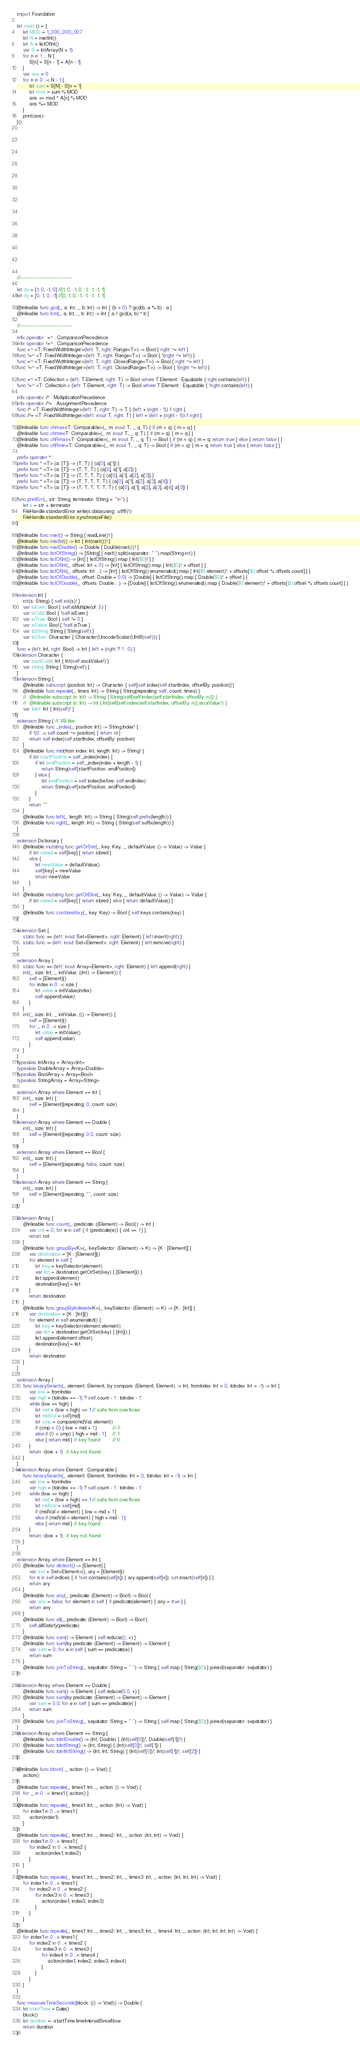Convert code to text. <code><loc_0><loc_0><loc_500><loc_500><_Swift_>import Foundation

let main: () = {
    let MOD = 1_000_000_007
    let N = nextInt()
    let A = listOfInt()
    var S = IntArray(N + 1)
    for n in 1 ... N {
        S[n] = S[n - 1] + A[n - 1]
    }
    var ans = 0
    for n in 0 ..< N - 1 {
        let sum = S[N] - S[n + 1]
        let mod = sum % MOD
        ans += mod * A[n] % MOD
        ans %= MOD
    }
    print(ans)
}()

























//----------------------------------

let dx = [1, 0, -1, 0] //[1, 0, -1, 0, -1,  1, -1, 1]
let dy = [0, 1, 0, -1] //[0, 1, 0, -1, -1, -1,  1, 1]

@inlinable func gcd(_ a: Int, _ b: Int) -> Int { (b > 0) ? gcd(b, a % b) : a }
@inlinable func lcm(_ a: Int, _ b: Int) -> Int { a / gcd(a, b) * b }

//----------------------------------

infix operator  =~ : ComparisonPrecedence
infix operator !=~ : ComparisonPrecedence
func =~ <T: FixedWidthInteger>(left: T, right: Range<T>) -> Bool { right ~= left }
func !=~ <T: FixedWidthInteger>(left: T, right: Range<T>) -> Bool { !(right ~= left) }
func =~ <T: FixedWidthInteger>(left: T, right: ClosedRange<T>) -> Bool { right ~= left }
func !=~ <T: FixedWidthInteger>(left: T, right: ClosedRange<T>) -> Bool { !(right ~= left) }

func =~ <T: Collection > (left: T.Element, right: T) -> Bool where T.Element : Equatable { right.contains(left) }
func !=~ <T: Collection > (left: T.Element, right: T) -> Bool where T.Element : Equatable { !right.contains(left) }

infix operator /^ : MultiplicationPrecedence
infix operator /^= : AssignmentPrecedence
func /^ <T: FixedWidthInteger>(left: T, right: T) -> T { (left + (right - 1)) / right }
func /^= <T: FixedWidthInteger>(left: inout T, right: T) { left = (left + (right - 1)) / right }

@inlinable func chmax<T: Comparable>(_ m: inout T, _ q: T) { if (m < q) { m = q } }
@inlinable func chmin<T: Comparable>(_ m: inout T, _ q: T) { if (m > q) { m = q } }
@inlinable func chRmax<T: Comparable>(_ m: inout T, _ q: T) -> Bool { if (m < q) { m = q; return true } else { return false } }
@inlinable func chRmin<T: Comparable>(_ m: inout T, _ q: T) -> Bool { if (m > q) { m = q; return true } else { return false } }

prefix operator *
prefix func * <T> (a: [T]) -> (T, T) { (a[0], a[1]) }
prefix func * <T> (a: [T]) -> (T, T, T) { (a[0], a[1], a[2]) }
prefix func * <T> (a: [T]) -> (T, T, T, T) { (a[0], a[1], a[2], a[3]) }
prefix func * <T> (a: [T]) -> (T, T, T, T, T) { (a[0], a[1], a[2], a[3], a[4]) }
prefix func * <T> (a: [T]) -> (T, T, T, T, T, T) { (a[0], a[1], a[2], a[3], a[4], a[5]) }

func printErr(_ str: String, terminator: String = "\n") {
    let s = str + terminator
    FileHandle.standardError.write(s.data(using: .utf8)!)
    FileHandle.standardError.synchronizeFile()
}

@inlinable func next() -> String { readLine()! }
@inlinable func nextInt() -> Int { Int(next())! }
@inlinable func nextDouble() -> Double { Double(next())! }
@inlinable func listOfString() -> [String] { next().split(separator: " ").map(String.init) }
@inlinable func listOfInt() -> [Int] { listOfString().map { Int($0)! } }
@inlinable func listOfInt(_ offset: Int = 0) -> [Int] { listOfString().map { Int($0)! + offset } }
@inlinable func listOfInt(_ offsets: Int ...) -> [Int] { listOfString().enumerated().map { Int($0.element)! + offsets[$0.offset % offsets.count] } }
@inlinable func listOfDouble(_ offset: Double = 0.0) -> [Double] { listOfString().map { Double($0)! + offset } }
@inlinable func listOfDouble(_ offsets: Double ...) -> [Double] { listOfString().enumerated().map { Double($0.element)! + offsets[$0.offset % offsets.count] } }

extension Int {
    init(s: String) { self.init(s)! }
    var isEven: Bool { self.isMultiple(of: 2) }
    var isOdd: Bool { !self.isEven }
    var isTrue: Bool { self != 0 }
    var isFalse: Bool { !self.isTrue }
    var toString: String { String(self) }
    var toChar: Character { Character(UnicodeScalar(UInt8(self))) }
}
func + (left: Int, right: Bool) -> Int { left + (right ? 1 : 0) }
extension Character {
    var asciiCode: Int { Int(self.asciiValue!) }
    var string: String { String(self) }
}
extension String {
    @inlinable subscript (position: Int) -> Character { self[self.index(self.startIndex, offsetBy: position)] }
    @inlinable func repeate(_ times: Int) -> String { String(repeating: self, count: times) }
    //  @inlinable subscript (n: Int) -> String { String(self[self.index(self.startIndex, offsetBy: n)]) }
    //  @inlinable subscript (n: Int) -> Int { Int(self[self.index(self.startIndex, offsetBy: n)].asciiValue!) }
    var toInt: Int { Int(self)! }
}
extension String { // VB like
    @inlinable func _index(_ position: Int) -> String.Index! {
        if !(0 ..< self.count ~= position) { return nil }
        return self.index(self.startIndex, offsetBy: position)
    }
    @inlinable func mid(from index: Int, length: Int) -> String! {
        if let startPosition = self._index(index) {
            if let endPosition = self._index(index + length - 1) {
                return String(self[startPosition...endPosition])
            } else {
                let endPosition = self.index(before: self.endIndex)
                return String(self[startPosition...endPosition])
            }
        }
        return ""
    }
    @inlinable func left(_ length: Int) -> String { String(self.prefix(length)) }
    @inlinable func right(_ length: Int) -> String { String(self.suffix(length)) }
}

extension Dictionary {
    @inlinable mutating func getOrSet(_ key: Key, _ defaultValue: () -> Value) -> Value {
        if let stored = self[key] { return stored }
        else {
            let newValue = defaultValue()
            self[key] = newValue
            return newValue
        }
    }
    @inlinable mutating func getOrElse(_ key: Key, _ defaultValue: () -> Value) -> Value {
        if let stored = self[key] { return stored } else { return defaultValue() }
    }
    @inlinable func containsKey(_ key: Key) -> Bool { self.keys.contains(key) }
}

extension Set {
    static func += (left: inout Set<Element>, right: Element) { left.insert(right) }
    static func -= (left: inout Set<Element>, right: Element) { left.remove(right) }
}

extension Array {
    static func += (left: inout Array<Element>, right: Element) { left.append(right) }
    init(_ size: Int, _ initValue: ((Int) -> Element)) {
        self = [Element]()
        for index in 0 ..< size {
            let value = initValue(index)
            self.append(value)
        }
    }
    init(_ size: Int, _ initValue: (() -> Element)) {
        self = [Element]()
        for _ in 0 ..< size {
            let value = initValue()
            self.append(value)
        }
    }
}
typealias IntArray = Array<Int>
typealias DoubleArray = Array<Double>
typealias BoolArray = Array<Bool>
typealias StringArray = Array<String>

extension Array where Element == Int {
    init(_ size: Int) {
        self = [Element](repeating: 0, count: size)
    }
}
extension Array where Element == Double {
    init(_ size: Int) {
        self = [Element](repeating: 0.0, count: size)
    }
}
extension Array where Element == Bool {
    init(_ size: Int) {
        self = [Element](repeating: false, count: size)
    }
}
extension Array where Element == String {
    init(_ size: Int) {
        self = [Element](repeating: "", count: size)
    }
}

extension Array {
    @inlinable func count(_ predicate: ((Element) -> Bool)) -> Int {
        var cnt = 0; for e in self { if (predicate(e)) { cnt += 1 } }
        return cnt
    }
    @inlinable func groupBy<K>(_ keySelector: (Element) -> K) -> [K : [Element]] {
        var destination = [K : [Element]]()
        for element in self {
            let key = keySelector(element)
            var list = destination.getOrSet(key) { [Element]() }
            list.append(element)
            destination[key] = list
        }
        return destination
    }
    @inlinable func groupByIndexed<K>(_ keySelector: (Element) -> K) -> [K : [Int]] {
        var destination = [K : [Int]]()
        for element in self.enumerated() {
            let key = keySelector(element.element)
            var list = destination.getOrSet(key) { [Int]() }
            list.append(element.offset)
            destination[key] = list
        }
        return destination
    }
}

extension Array {
    func binarySearch(_ element: Element, by compare: (Element, Element) -> Int, fromIndex: Int = 0, toIndex: Int = -1) -> Int {
        var low = fromIndex
        var high = (toIndex == -1) ? self.count - 1 : toIndex - 1
        while (low <= high) {
            let mid = (low + high) >> 1 // safe from overflows
            let midVal = self[mid]
            let cmp = compare(midVal, element)
            if (cmp < 0) { low = mid + 1 }          //-1
            else if (0 < cmp) { high = mid - 1 }    // 1
            else { return mid } // key found        // 0
        }
        return -(low + 1)  // key not found
    }
}
extension Array where Element : Comparable {
    func binarySearch(_ element: Element, fromIndex: Int = 0, toIndex: Int = -1) -> Int {
        var low = fromIndex
        var high = (toIndex == -1) ? self.count - 1 : toIndex - 1
        while (low <= high) {
            let mid = (low + high) >> 1 // safe from overflows
            let midVal = self[mid]
            if (midVal < element) { low = mid + 1 }
            else if (midVal > element) { high = mid - 1 }
            else { return mid } // key found
        }
        return -(low + 1)  // key not found
    }
}

extension Array where Element == Int {
    @inlinable func distinct() -> [Element] {
        var set = Set<Element>(), ary = [Element]()
        for n in self.indices { if !set.contains(self[n]) { ary.append(self[n]); set.insert(self[n]) } }
        return ary
    }
    @inlinable func any(_ predicate: (Element) -> Bool) -> Bool {
        var any = false; for element in self { if predicate(element) { any = true } }
        return any
    }
    @inlinable func all(_ predicate: (Element) -> Bool) -> Bool {
        self.allSatisfy(predicate)
    }
    @inlinable func sum() -> Element { self.reduce(0, +) }
    @inlinable func sum(by predicate: (Element) -> Element) -> Element {
        var sum = 0; for e in self { sum += predicate(e) }
        return sum
    }
    @inlinable func joinToString(_ sepatator: String = " ") -> String { self.map { String($0) }.joined(separator: sepatator) }
}

extension Array where Element == Double {
    @inlinable func sum() -> Element { self.reduce(0.0, +) }
    @inlinable func sum(by predicate: (Element) -> Element) -> Element {
        var sum = 0.0; for e in self { sum += predicate(e) }
        return sum
    }
    @inlinable func joinToString(_ sepatator: String = " ") -> String { self.map { String($0) }.joined(separator: sepatator) }
}
extension Array where Element == String {
    @inlinable func toIntDouble() -> (Int, Double) { (Int(self[0])!, Double(self[1])!) }
    @inlinable func toIntString() -> (Int, String) { (Int(self[0])!, self[1]) }
    @inlinable func toIntIntString() -> (Int, Int, String) { (Int(self[0])!, Int(self[1])!, self[2]) }
}

@inlinable func block( _ action: () -> Void) {
    action()
}
@inlinable func repeate(_ times1: Int, _ action: () -> Void) {
    for _ in 0 ..< times1 { action() }
}
@inlinable func repeate(_ times1: Int, _ action: (Int) -> Void) {
    for index1 in 0 ..< times1 {
        action(index1)
    }
}
@inlinable func repeate(_ times1: Int, _ times2: Int, _ action: (Int, Int) -> Void) {
    for index1 in 0 ..< times1 {
        for index2 in 0 ..< times2 {
            action(index1, index2)
        }
    }
}
@inlinable func repeate(_ times1: Int, _ times2: Int, _ times3: Int, _ action: (Int, Int, Int) -> Void) {
    for index1 in 0 ..< times1 {
        for index2 in 0 ..< times2 {
            for index3 in 0 ..< times3 {
                action(index1, index2, index3)
            }
        }
    }
}
@inlinable func repeate(_ times1: Int, _ times2: Int, _ times3: Int, _ times4: Int, _ action: (Int, Int, Int, Int) -> Void) {
    for index1 in 0 ..< times1 {
        for index2 in 0 ..< times2 {
            for index3 in 0 ..< times3 {
                for index4 in 0 ..< times4 {
                    action(index1, index2, index3, index4)
                }
            }
        }
    }
}

func measureTimeSeconds(block: (() -> Void)) -> Double {
    let startTime = Date()
    block()
    let duration = -startTime.timeIntervalSinceNow
    return duration
}
</code> 